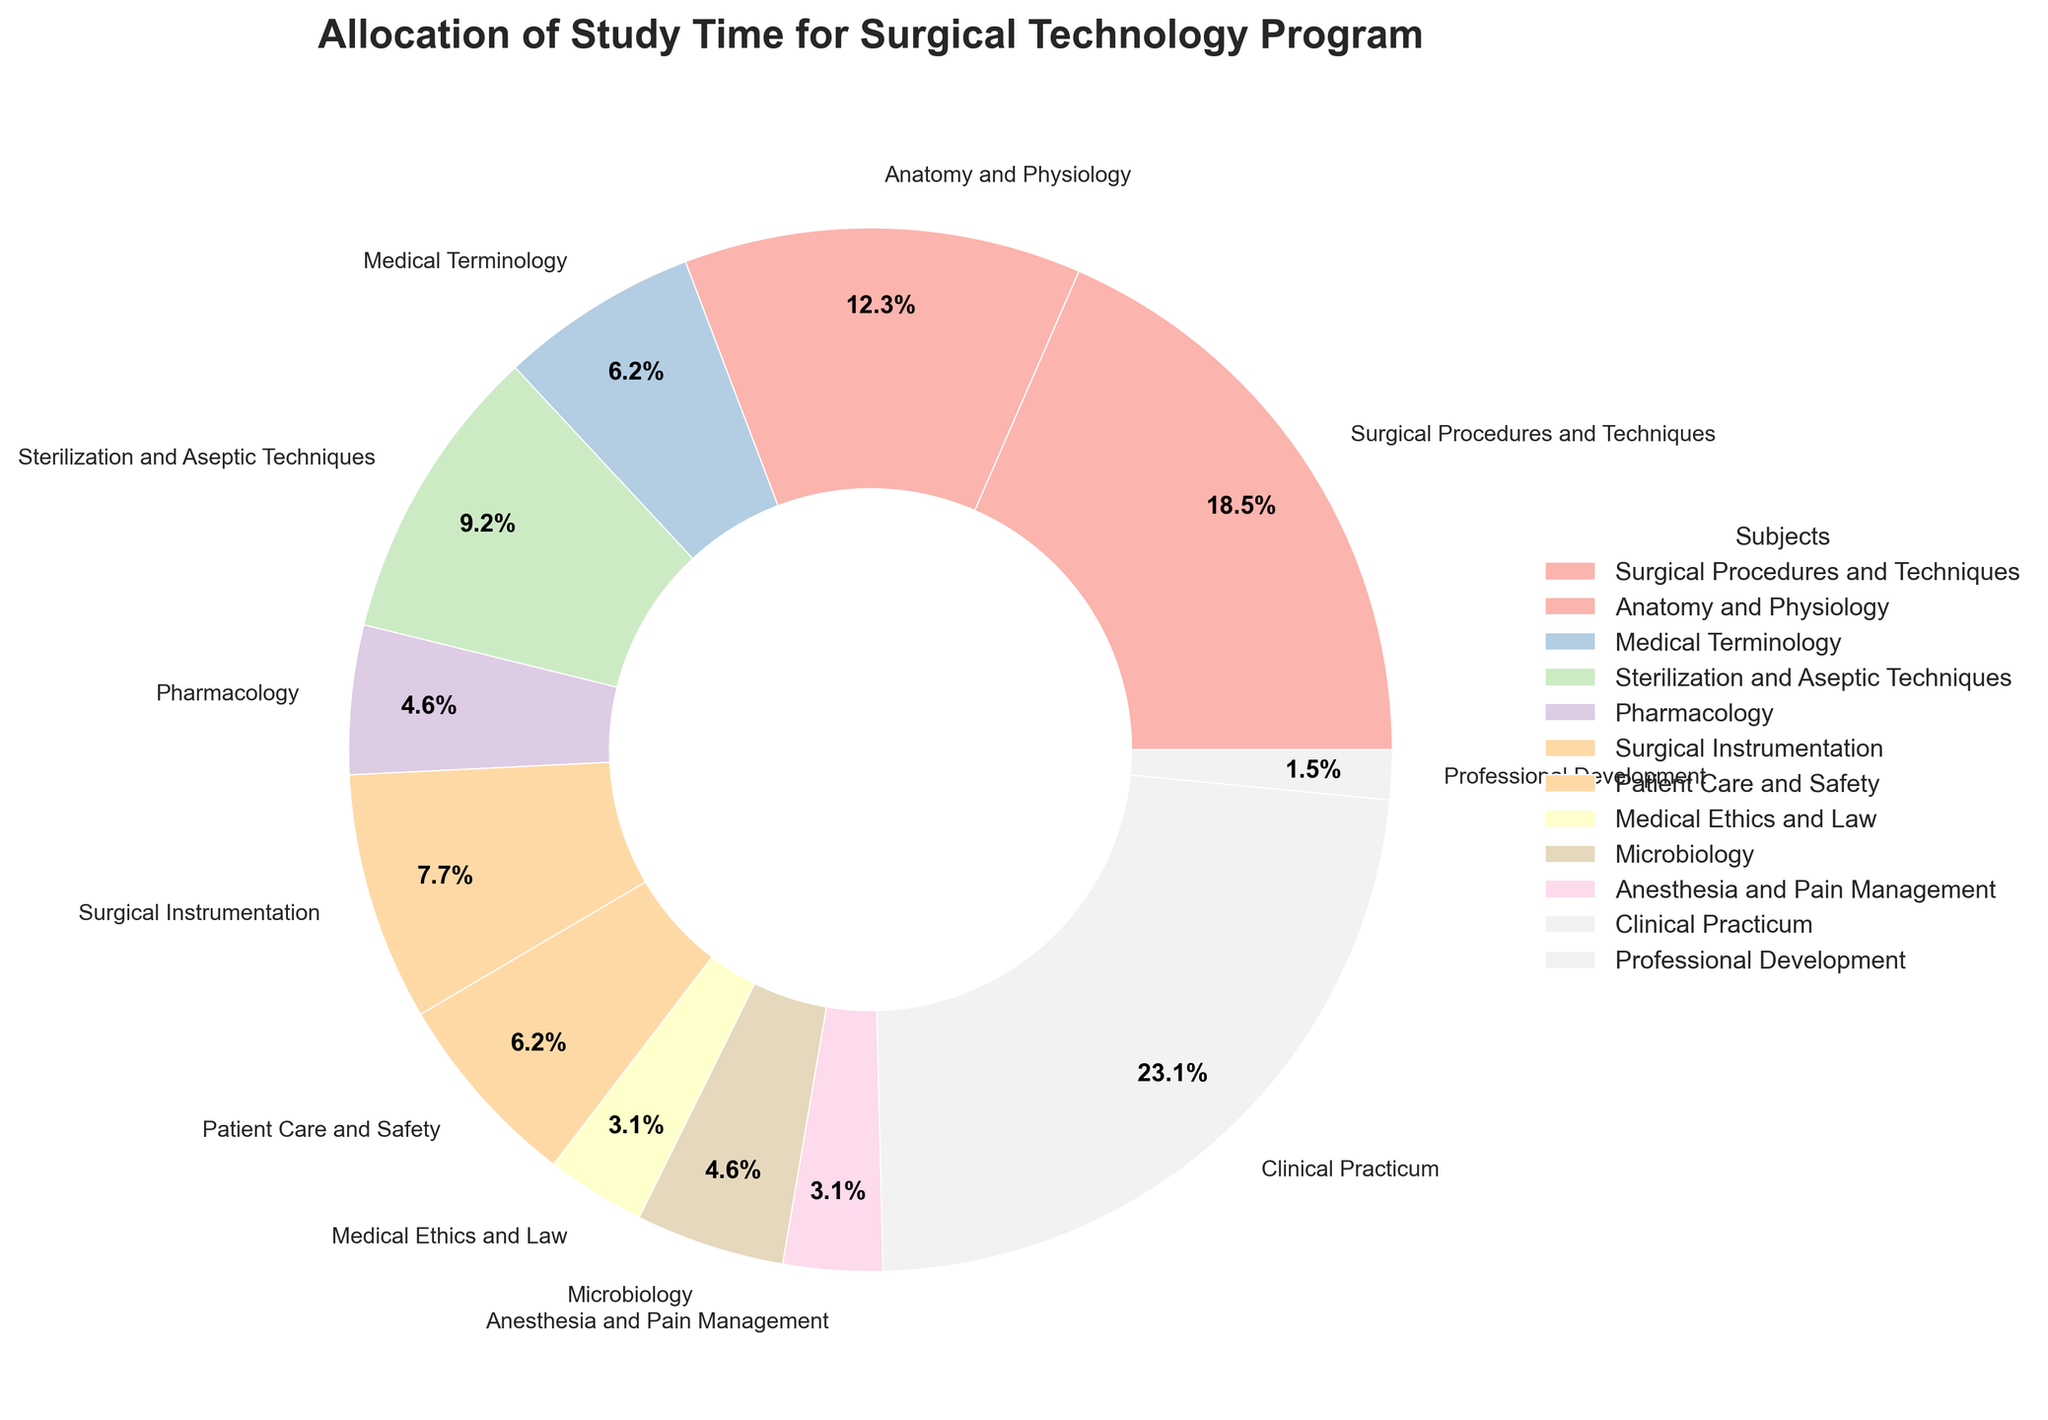What's the total combined study time allocated for "Anatomy and Physiology" and "Medical Terminology"? From the figure, we see "Anatomy and Physiology" has 8 hours, and "Medical Terminology" has 4 hours. Adding these together gives 8 + 4 = 12 hours.
Answer: 12 hours Which subject has the highest allocation of study time? Observing the pie chart, we see that "Clinical Practicum" takes the largest segment, which translates to the highest allocation of study time.
Answer: Clinical Practicum What is the difference in study hours per week between "Surgical Procedures and Techniques" and "Sterilization and Aseptic Techniques"? From the pie chart, "Surgical Procedures and Techniques" has 12 hours, and "Sterilization and Aseptic Techniques" has 6 hours. The difference is 12 - 6 = 6 hours.
Answer: 6 hours What percentage of the total study time is dedicated to "Pharmacology" and "Microbiology" combined? From the chart, "Pharmacology" takes 3 hours and "Microbiology" takes 3 hours. Combining these gives 3 + 3 = 6 hours. To find the percentage: Total hours per week = 65. (6/65) * 100 ≈ 9.2%.
Answer: 9.2% Which subject has fewer hours, "Medical Ethics and Law" or "Anesthesia and Pain Management"? According to the chart, both "Medical Ethics and Law" and "Anesthesia and Pain Management" are allocated 2 hours each, hence they have the same number of hours.
Answer: Same hours (2 hours) What is the sum of study hours for "Surgical Instrumentation" and "Patient Care and Safety"? According to the pie chart, "Surgical Instrumentation" has 5 hours, and "Patient Care and Safety" has 4 hours. Summing these gives 5 + 4 = 9 hours.
Answer: 9 hours What proportion of the pie chart is accounted for by "Medical Ethics and Law"? The pie chart shows "Medical Ethics and Law" with a slice labeled 2 hours out of a total of 65 hours per week. Calculating this: (2/65) * 100 ≈ 3.1%.
Answer: 3.1% If you combine "Surgical Procedures and Techniques," "Sterilization and Aseptic Techniques," and "Surgical Instrumentation," what is the total study time? From the chart: "Surgical Procedures and Techniques" = 12 hours, "Sterilization and Aseptic Techniques" = 6 hours, "Surgical Instrumentation" = 5 hours. Adding these gives 12 + 6 + 5 = 23 hours.
Answer: 23 hours What is the visual indication of the subject with the least study time allocation? Observing the pie chart, the subject with the smallest wedge indicates the least allocation, which is "Professional Development" at 1 hour.
Answer: Professional Development (1 hour) How many subjects are allocated more than 5 hours per week? By inspecting the pie chart, the subjects with more than 5 hours allocation are: "Clinical Practicum" (15), "Surgical Procedures and Techniques" (12), "Anatomy and Physiology" (8), and "Sterilization and Aseptic Techniques" (6). There are 4 subjects in total.
Answer: 4 subjects 